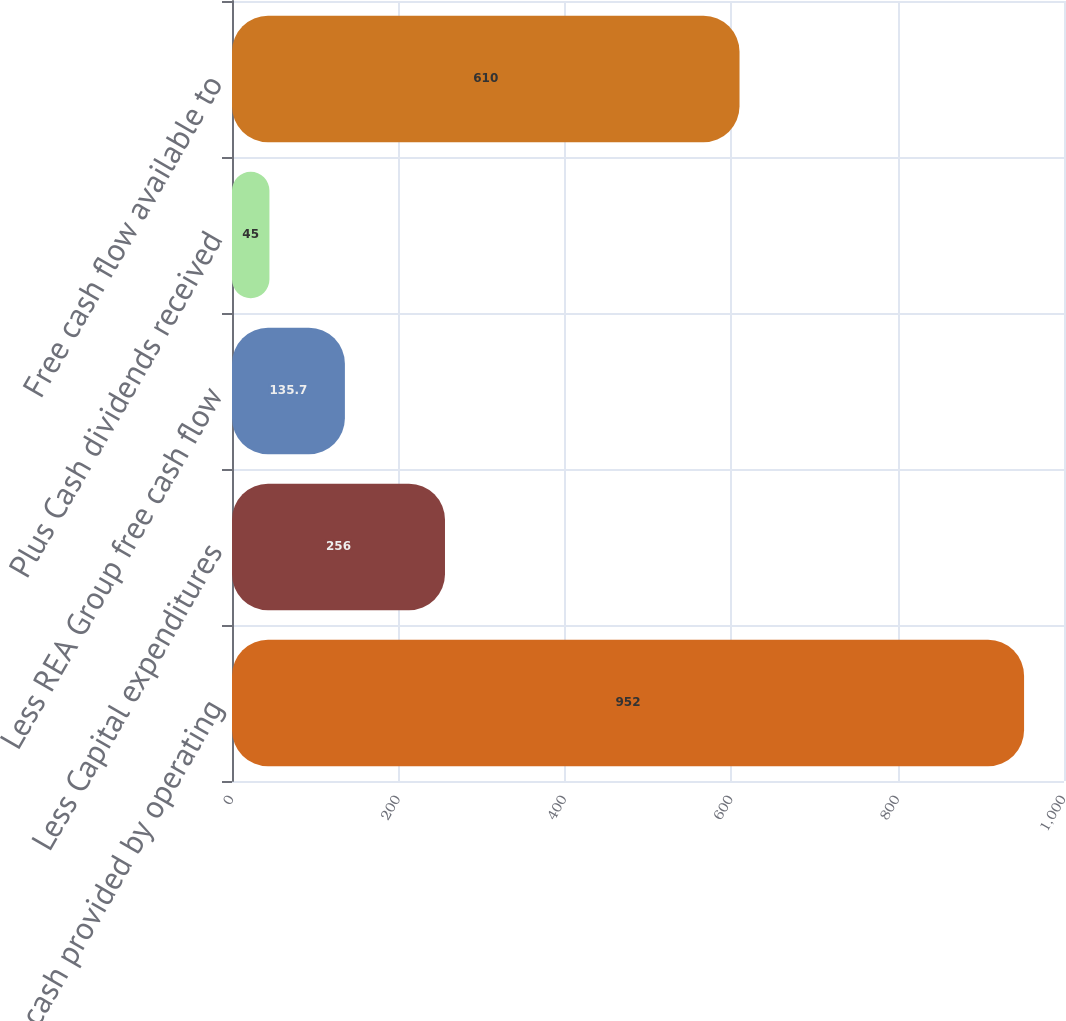Convert chart to OTSL. <chart><loc_0><loc_0><loc_500><loc_500><bar_chart><fcel>Net cash provided by operating<fcel>Less Capital expenditures<fcel>Less REA Group free cash flow<fcel>Plus Cash dividends received<fcel>Free cash flow available to<nl><fcel>952<fcel>256<fcel>135.7<fcel>45<fcel>610<nl></chart> 